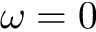<formula> <loc_0><loc_0><loc_500><loc_500>\omega = 0</formula> 